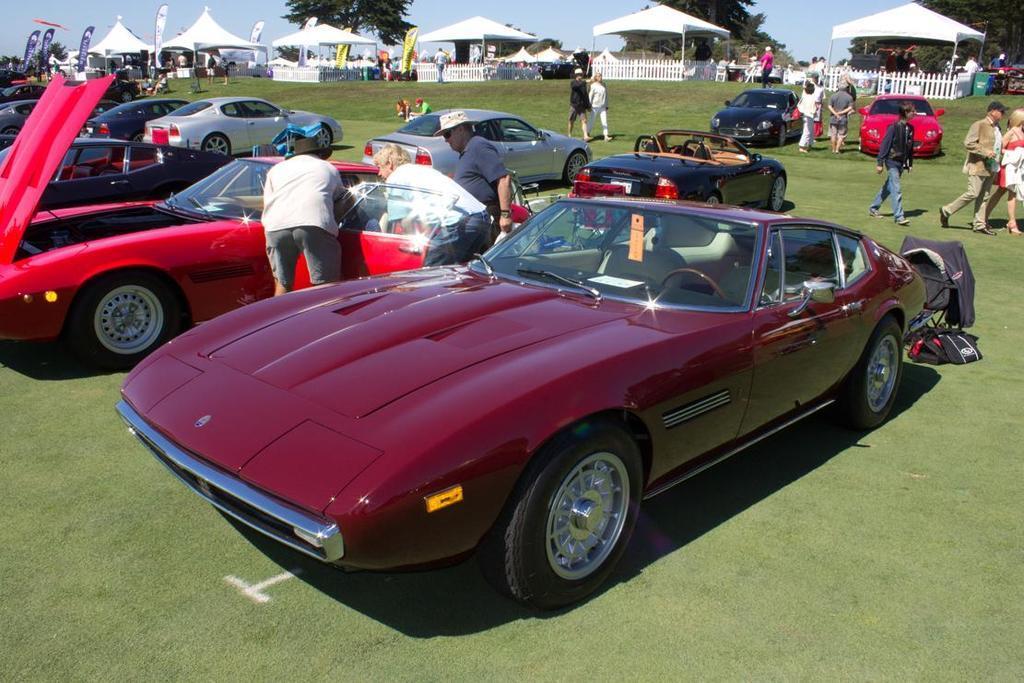Describe this image in one or two sentences. In this image we can see some vehicles and a group of people on the ground. We can also see grass, the tents, fence, trees and the sky. 